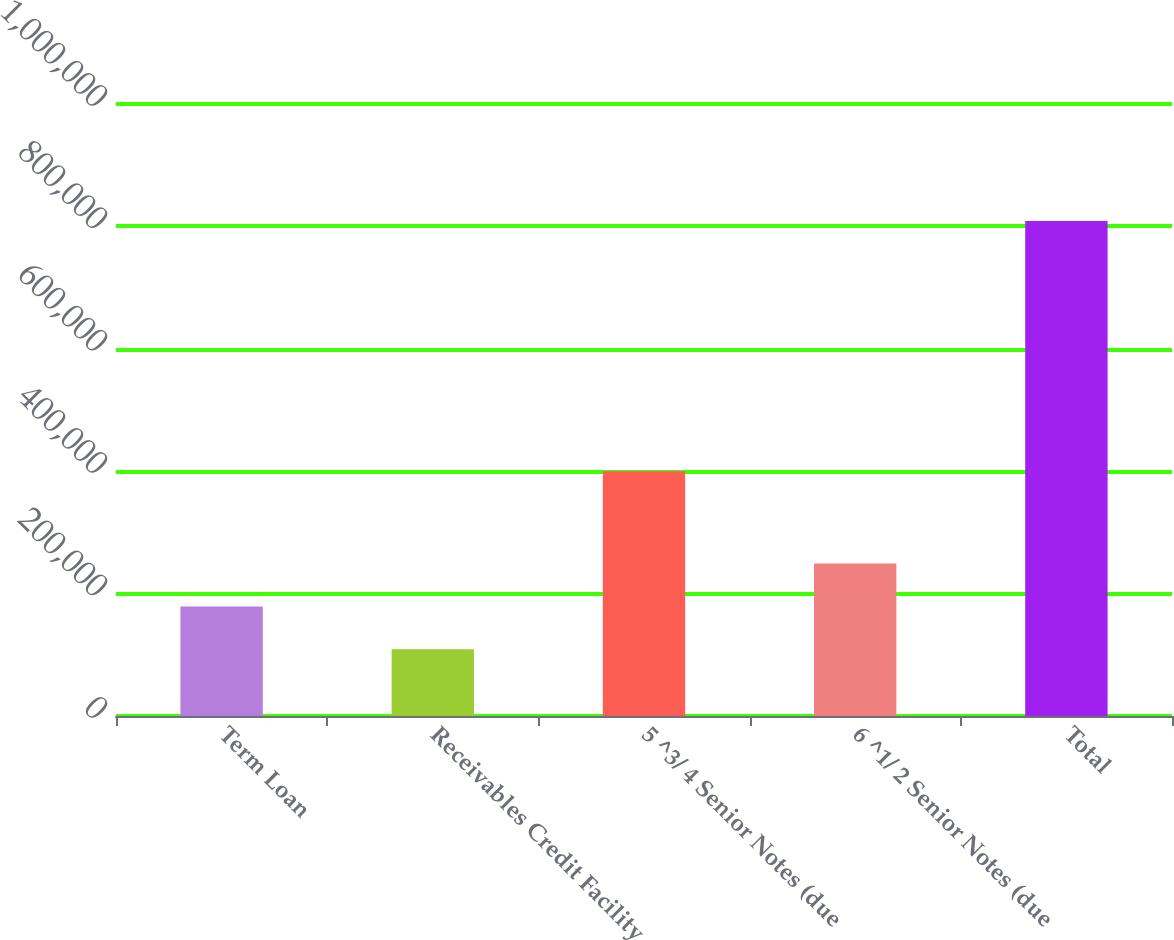<chart> <loc_0><loc_0><loc_500><loc_500><bar_chart><fcel>Term Loan<fcel>Receivables Credit Facility<fcel>5 ^3/ 4 Senior Notes (due<fcel>6 ^1/ 2 Senior Notes (due<fcel>Total<nl><fcel>179000<fcel>109000<fcel>400000<fcel>249000<fcel>809000<nl></chart> 